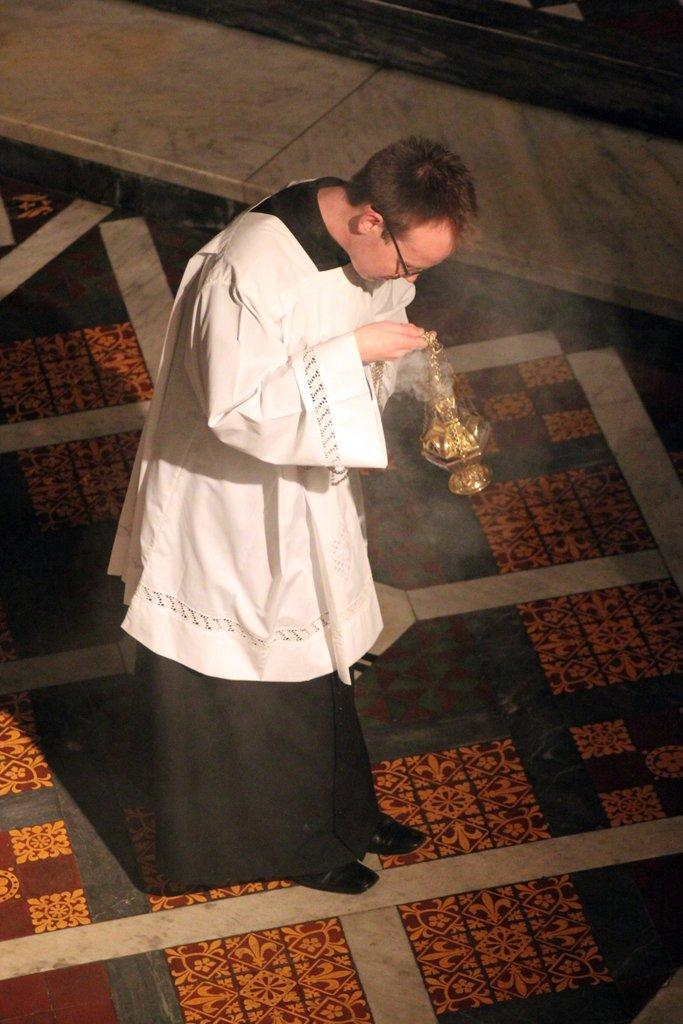Who is present in the image? There is a man in the image. What can be observed about the man's appearance? The man is wearing spectacles. What is the man doing in the image? The man is holding an object with his hands. Where is the man located in the image? The man is standing on the floor. What type of yarn is the man using to knit in the image? There is no yarn or knitting activity present in the image. What is the aftermath of the event depicted in the image? There is no event or aftermath depicted in the image; it simply shows a man standing and holding an object. 